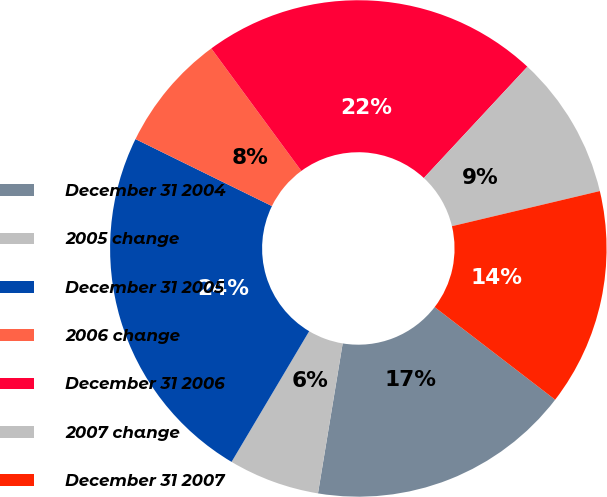Convert chart to OTSL. <chart><loc_0><loc_0><loc_500><loc_500><pie_chart><fcel>December 31 2004<fcel>2005 change<fcel>December 31 2005<fcel>2006 change<fcel>December 31 2006<fcel>2007 change<fcel>December 31 2007<nl><fcel>17.17%<fcel>5.93%<fcel>23.73%<fcel>7.65%<fcel>22.01%<fcel>9.36%<fcel>14.14%<nl></chart> 